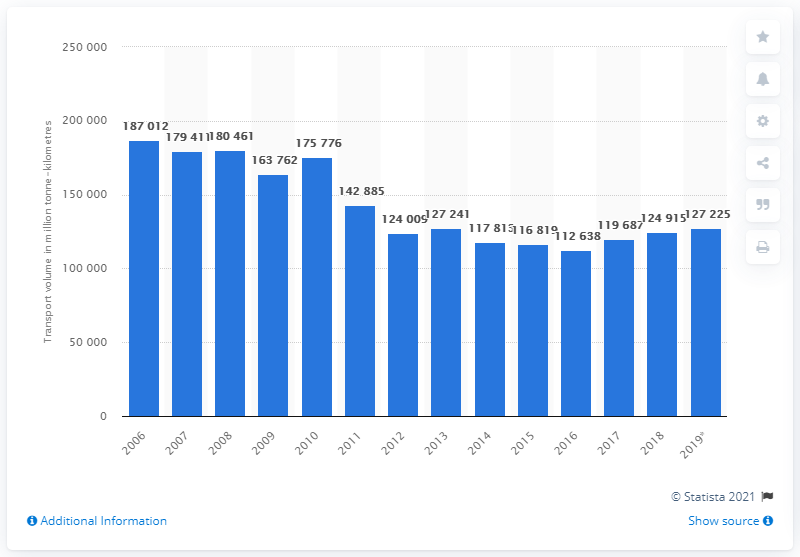Outline some significant characteristics in this image. In 2006, the highest transport volume was achieved in Italy. In 2019, the road freight transport volume in Italy was 127,225 units. 